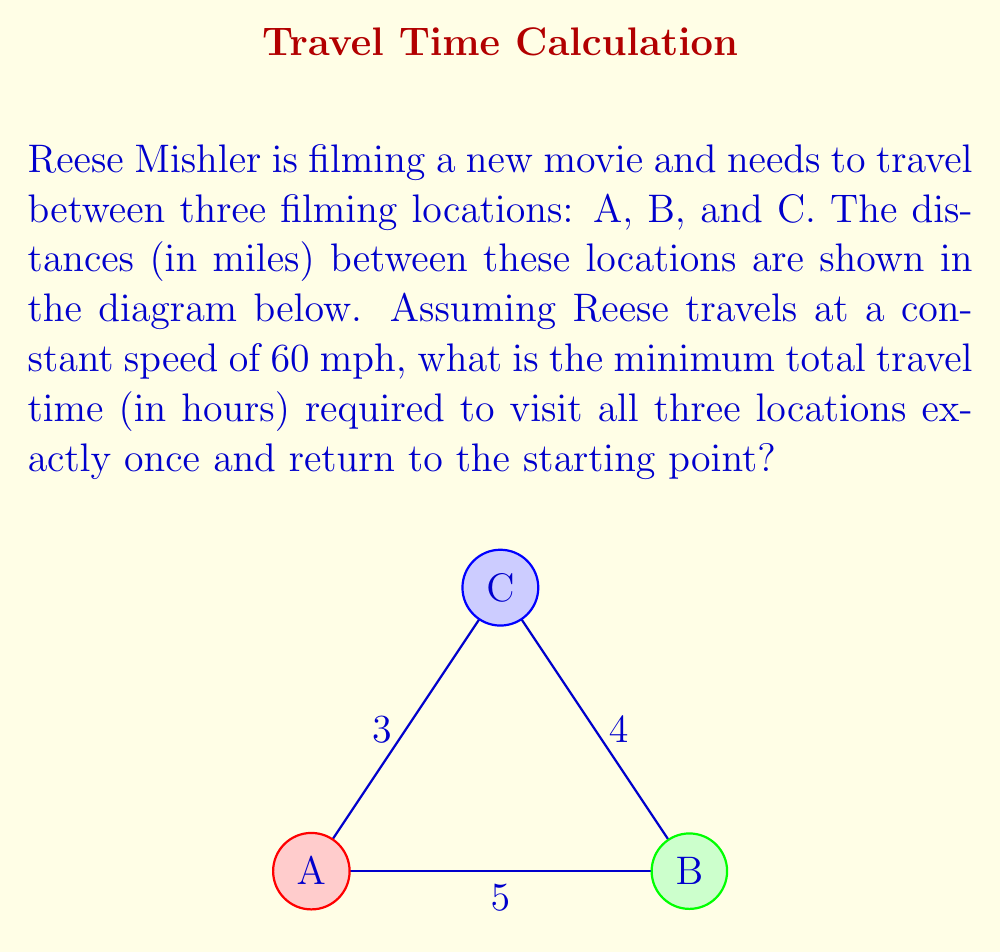Teach me how to tackle this problem. To solve this problem, we need to follow these steps:

1) First, we need to find the shortest route that visits all locations once and returns to the starting point. This is known as the Traveling Salesman Problem.

2) For three locations, there are only two possible routes:
   A → B → C → A
   A → C → B → A

3) Let's calculate the total distance for each route:
   
   Route 1 (A → B → C → A): 5 + 4 + 3 = 12 miles
   Route 2 (A → C → B → A): 3 + 4 + 5 = 12 miles

4) Both routes have the same total distance of 12 miles, so either can be chosen as the optimal route.

5) Now that we have the total distance, we can calculate the travel time using the formula:
   
   $$ \text{Time} = \frac{\text{Distance}}{\text{Speed}} $$

6) Plugging in our values:

   $$ \text{Time} = \frac{12 \text{ miles}}{60 \text{ miles/hour}} = 0.2 \text{ hours} $$

Therefore, the minimum total travel time is 0.2 hours.
Answer: 0.2 hours 